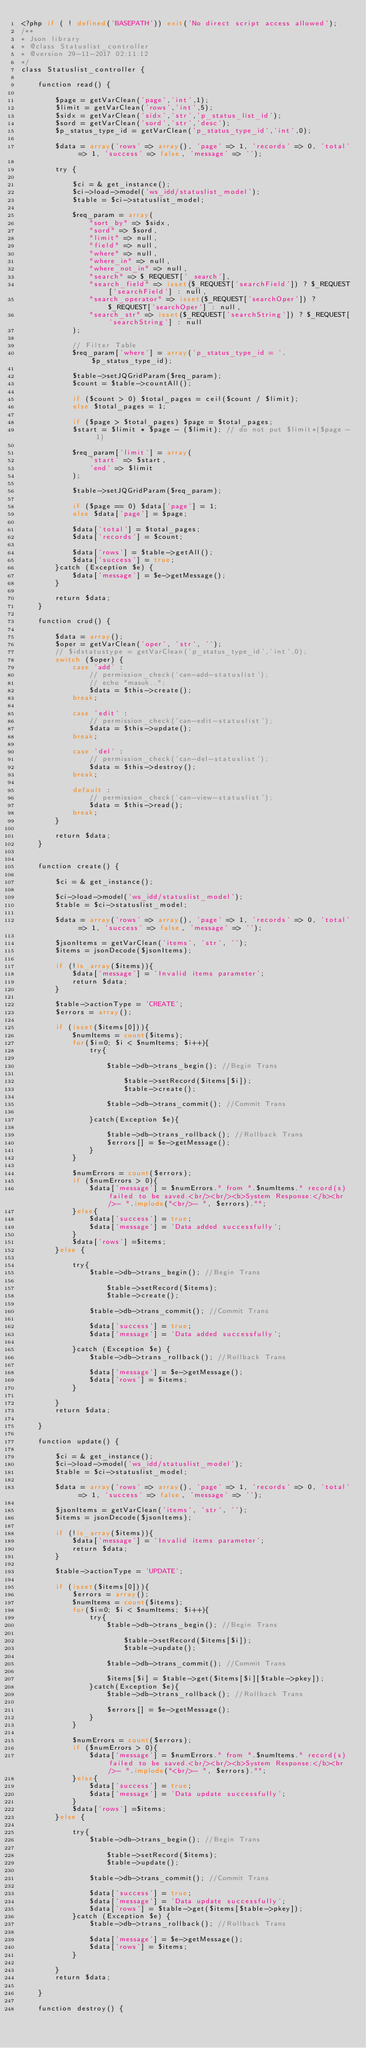Convert code to text. <code><loc_0><loc_0><loc_500><loc_500><_PHP_><?php if ( ! defined('BASEPATH')) exit('No direct script access allowed');
/**
* Json library
* @class Statuslist_controller
* @version 29-11-2017 02:11:12
*/
class Statuslist_controller {

    function read() {

        $page = getVarClean('page','int',1);
        $limit = getVarClean('rows','int',5);
        $sidx = getVarClean('sidx','str','p_status_list_id');
        $sord = getVarClean('sord','str','desc');
        $p_status_type_id = getVarClean('p_status_type_id','int',0);

        $data = array('rows' => array(), 'page' => 1, 'records' => 0, 'total' => 1, 'success' => false, 'message' => '');

        try {

            $ci = & get_instance();
            $ci->load->model('ws_idd/statuslist_model');
            $table = $ci->statuslist_model;

            $req_param = array(
                "sort_by" => $sidx,
                "sord" => $sord,
                "limit" => null,
                "field" => null,
                "where" => null,
                "where_in" => null,
                "where_not_in" => null,
                "search" => $_REQUEST['_search'],
                "search_field" => isset($_REQUEST['searchField']) ? $_REQUEST['searchField'] : null,
                "search_operator" => isset($_REQUEST['searchOper']) ? $_REQUEST['searchOper'] : null,
                "search_str" => isset($_REQUEST['searchString']) ? $_REQUEST['searchString'] : null
            );

            // Filter Table
            $req_param['where'] = array('p_status_type_id = '. $p_status_type_id);

            $table->setJQGridParam($req_param);
            $count = $table->countAll();

            if ($count > 0) $total_pages = ceil($count / $limit);
            else $total_pages = 1;

            if ($page > $total_pages) $page = $total_pages;
            $start = $limit * $page - ($limit); // do not put $limit*($page - 1)

            $req_param['limit'] = array(
                'start' => $start,
                'end' => $limit
            );

            $table->setJQGridParam($req_param);

            if ($page == 0) $data['page'] = 1;
            else $data['page'] = $page;

            $data['total'] = $total_pages;
            $data['records'] = $count;

            $data['rows'] = $table->getAll();
            $data['success'] = true;
        }catch (Exception $e) {
            $data['message'] = $e->getMessage();
        }

        return $data;
    }

    function crud() {

        $data = array();
        $oper = getVarClean('oper', 'str', '');
        // $idstatustype = getVarClean('p_status_type_id','int',0);
        switch ($oper) {
            case 'add' :
                // permission_check('can-add-statuslist');
				// echo "masuk..";
                $data = $this->create();
            break;

            case 'edit' :
                // permission_check('can-edit-statuslist');
                $data = $this->update();
            break;

            case 'del' :
                // permission_check('can-del-statuslist');
                $data = $this->destroy();
            break;

            default :
                // permission_check('can-view-statuslist');
                $data = $this->read();
            break;
        }

        return $data;
    }


    function create() {

        $ci = & get_instance();
  	
        $ci->load->model('ws_idd/statuslist_model');
        $table = $ci->statuslist_model;
        
        $data = array('rows' => array(), 'page' => 1, 'records' => 0, 'total' => 1, 'success' => false, 'message' => '');

        $jsonItems = getVarClean('items', 'str', '');
        $items = jsonDecode($jsonItems);

        if (!is_array($items)){
            $data['message'] = 'Invalid items parameter';
            return $data;
        }

        $table->actionType = 'CREATE';
        $errors = array();

        if (isset($items[0])){
            $numItems = count($items);
            for($i=0; $i < $numItems; $i++){
                try{

                    $table->db->trans_begin(); //Begin Trans

                        $table->setRecord($items[$i]);
                        $table->create();

                    $table->db->trans_commit(); //Commit Trans

                }catch(Exception $e){

                    $table->db->trans_rollback(); //Rollback Trans
                    $errors[] = $e->getMessage();
                }
            }

            $numErrors = count($errors);
            if ($numErrors > 0){
                $data['message'] = $numErrors." from ".$numItems." record(s) failed to be saved.<br/><br/><b>System Response:</b><br/>- ".implode("<br/>- ", $errors)."";
            }else{
                $data['success'] = true;
                $data['message'] = 'Data added successfully';
            }
            $data['rows'] =$items;
        }else {

            try{
                $table->db->trans_begin(); //Begin Trans

                    $table->setRecord($items);
                    $table->create();

                $table->db->trans_commit(); //Commit Trans

                $data['success'] = true;
                $data['message'] = 'Data added successfully';

            }catch (Exception $e) {
                $table->db->trans_rollback(); //Rollback Trans

                $data['message'] = $e->getMessage();
                $data['rows'] = $items;
            }

        }
        return $data;

    }

    function update() {

        $ci = & get_instance();
        $ci->load->model('ws_idd/statuslist_model');
        $table = $ci->statuslist_model;

        $data = array('rows' => array(), 'page' => 1, 'records' => 0, 'total' => 1, 'success' => false, 'message' => '');

        $jsonItems = getVarClean('items', 'str', '');
        $items = jsonDecode($jsonItems);

        if (!is_array($items)){
            $data['message'] = 'Invalid items parameter';
            return $data;
        }

        $table->actionType = 'UPDATE';

        if (isset($items[0])){
            $errors = array();
            $numItems = count($items);
            for($i=0; $i < $numItems; $i++){
                try{
                    $table->db->trans_begin(); //Begin Trans

                        $table->setRecord($items[$i]);
                        $table->update();

                    $table->db->trans_commit(); //Commit Trans

                    $items[$i] = $table->get($items[$i][$table->pkey]);
                }catch(Exception $e){
                    $table->db->trans_rollback(); //Rollback Trans

                    $errors[] = $e->getMessage();
                }
            }

            $numErrors = count($errors);
            if ($numErrors > 0){
                $data['message'] = $numErrors." from ".$numItems." record(s) failed to be saved.<br/><br/><b>System Response:</b><br/>- ".implode("<br/>- ", $errors)."";
            }else{
                $data['success'] = true;
                $data['message'] = 'Data update successfully';
            }
            $data['rows'] =$items;
        }else {

            try{
                $table->db->trans_begin(); //Begin Trans

                    $table->setRecord($items);
                    $table->update();

                $table->db->trans_commit(); //Commit Trans

                $data['success'] = true;
                $data['message'] = 'Data update successfully';
                $data['rows'] = $table->get($items[$table->pkey]);
            }catch (Exception $e) {
                $table->db->trans_rollback(); //Rollback Trans

                $data['message'] = $e->getMessage();
                $data['rows'] = $items;
            }

        }
        return $data;

    }

    function destroy() {</code> 